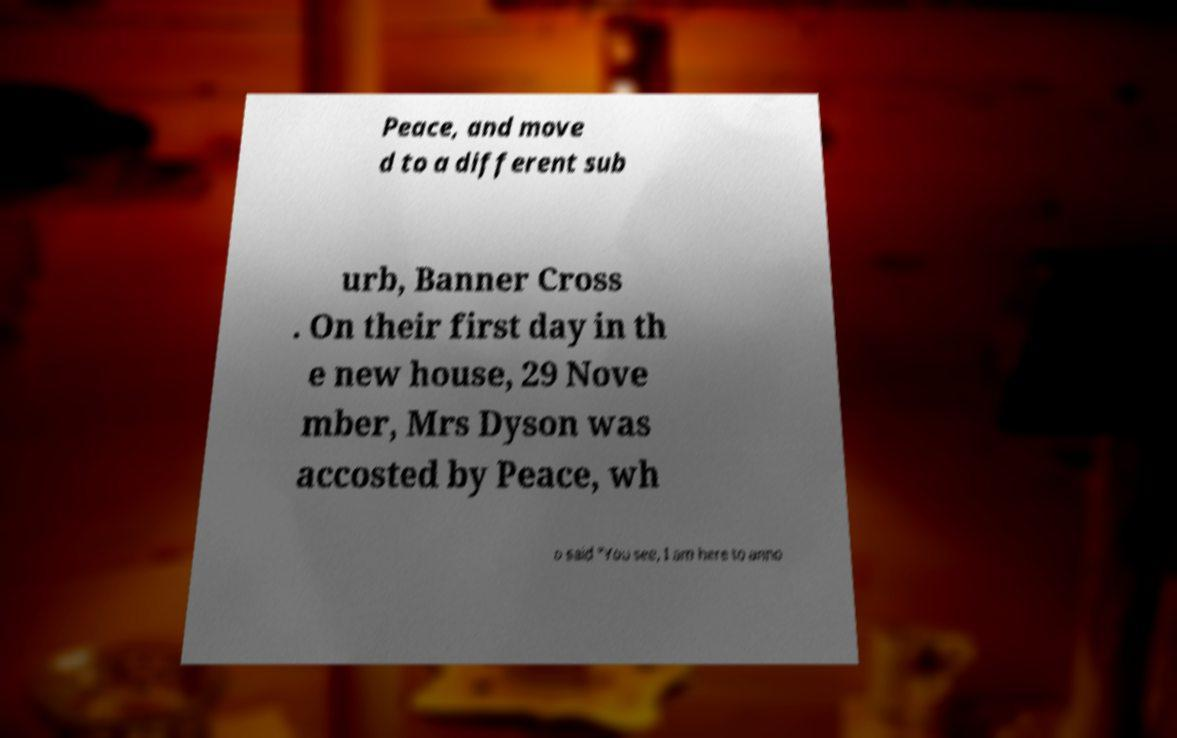Could you assist in decoding the text presented in this image and type it out clearly? Peace, and move d to a different sub urb, Banner Cross . On their first day in th e new house, 29 Nove mber, Mrs Dyson was accosted by Peace, wh o said "You see, I am here to anno 